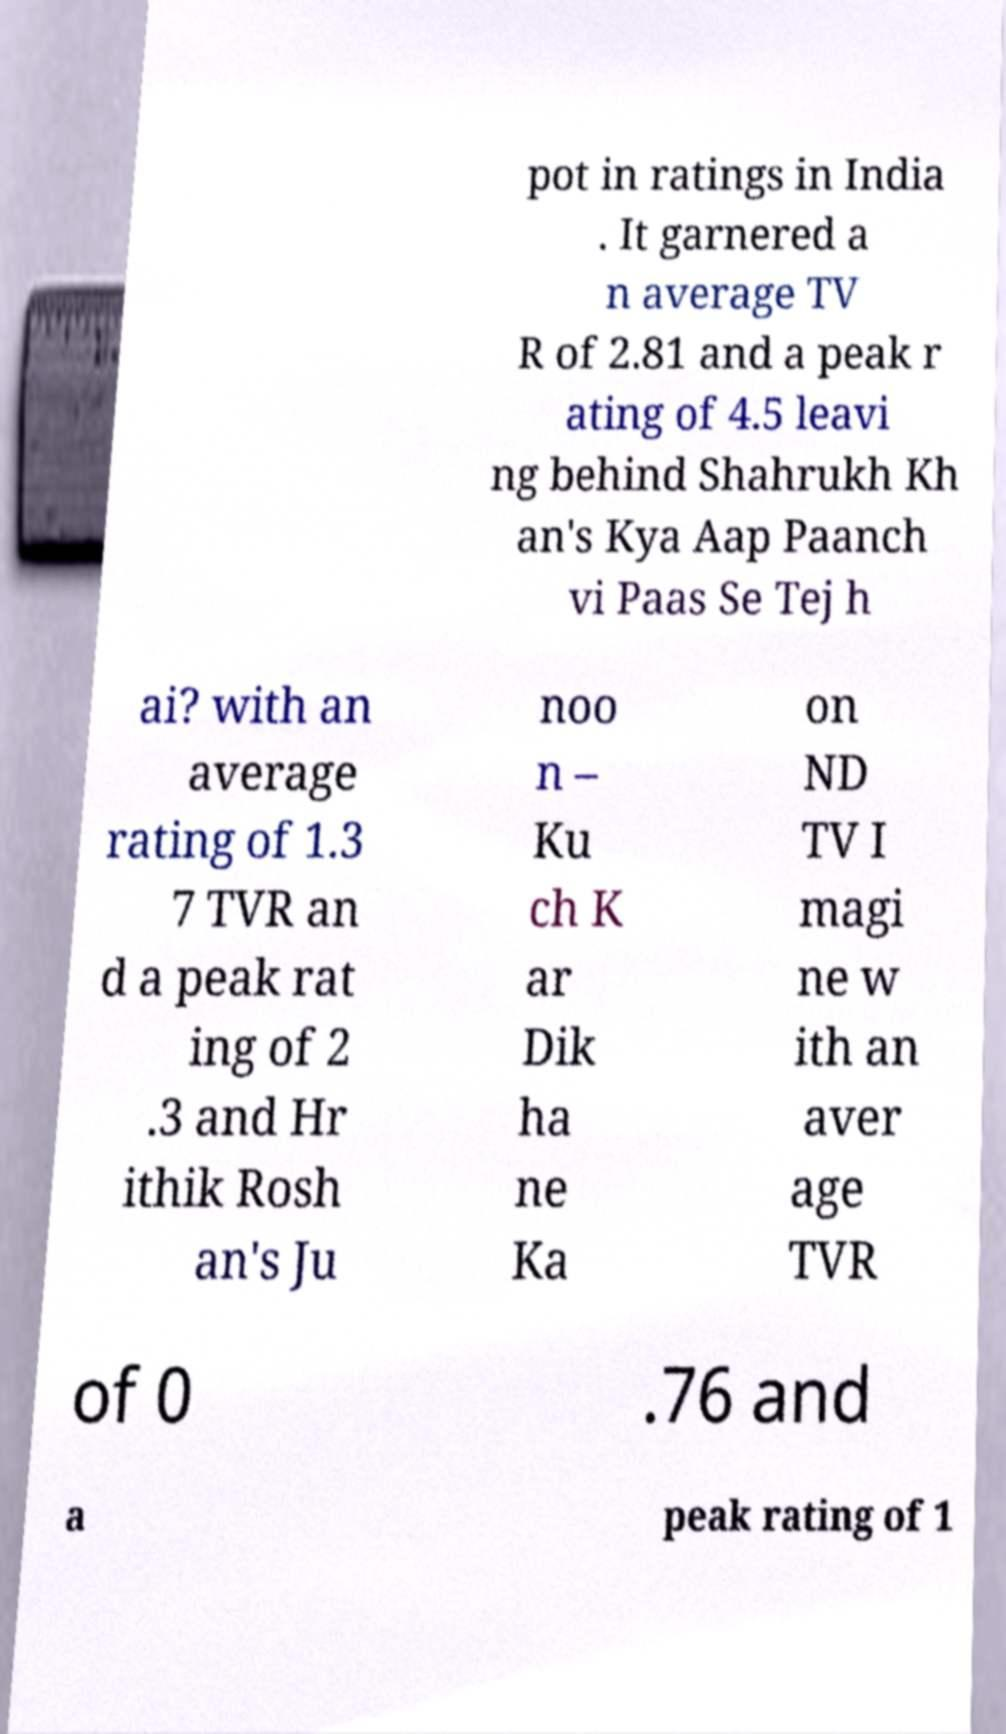Can you accurately transcribe the text from the provided image for me? pot in ratings in India . It garnered a n average TV R of 2.81 and a peak r ating of 4.5 leavi ng behind Shahrukh Kh an's Kya Aap Paanch vi Paas Se Tej h ai? with an average rating of 1.3 7 TVR an d a peak rat ing of 2 .3 and Hr ithik Rosh an's Ju noo n – Ku ch K ar Dik ha ne Ka on ND TV I magi ne w ith an aver age TVR of 0 .76 and a peak rating of 1 